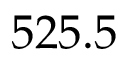Convert formula to latex. <formula><loc_0><loc_0><loc_500><loc_500>5 2 5 . 5</formula> 